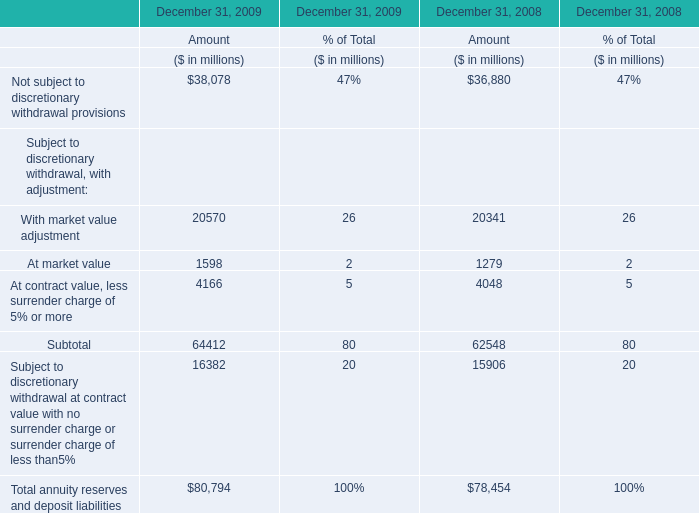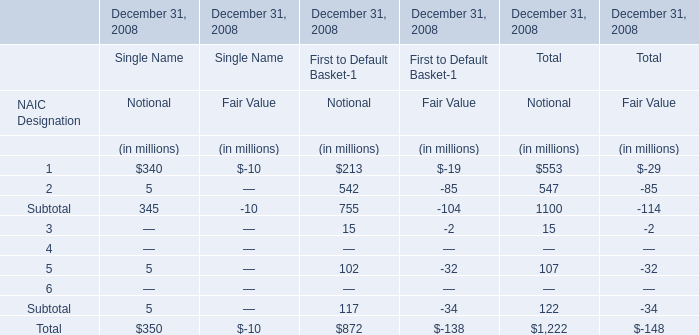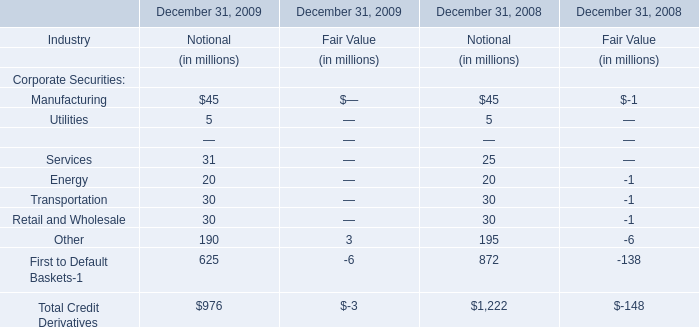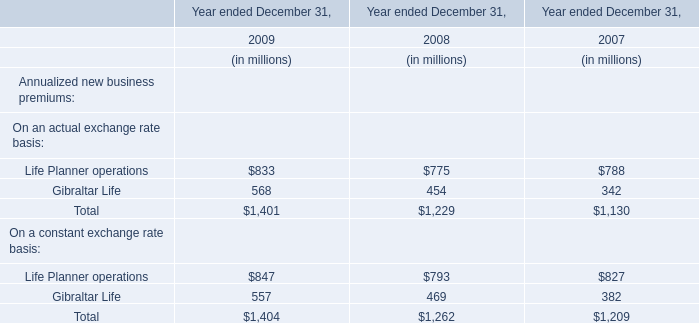what was the percentage change in the company 2019s gross unrecognized tax benefits from 2011 to 2012 
Computations: ((52.4 - 32.1) - 32.1)
Answer: -11.8. 